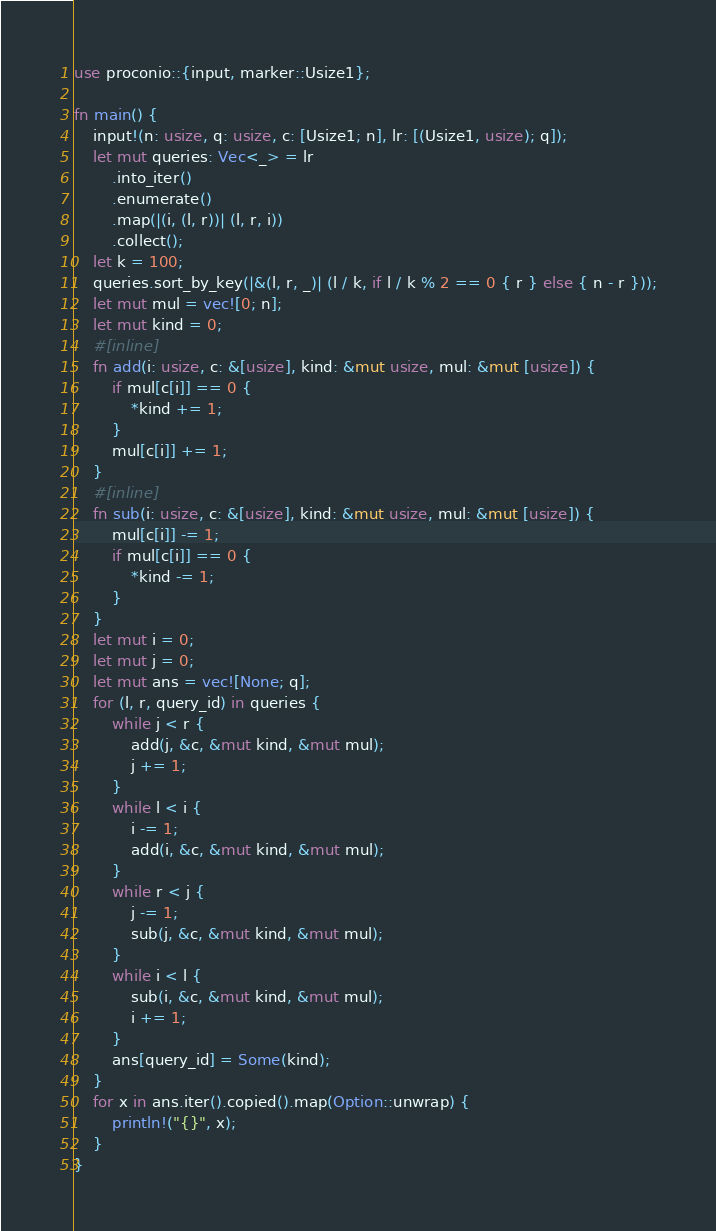<code> <loc_0><loc_0><loc_500><loc_500><_Rust_>use proconio::{input, marker::Usize1};

fn main() {
    input!(n: usize, q: usize, c: [Usize1; n], lr: [(Usize1, usize); q]);
    let mut queries: Vec<_> = lr
        .into_iter()
        .enumerate()
        .map(|(i, (l, r))| (l, r, i))
        .collect();
    let k = 100;
    queries.sort_by_key(|&(l, r, _)| (l / k, if l / k % 2 == 0 { r } else { n - r }));
    let mut mul = vec![0; n];
    let mut kind = 0;
    #[inline]
    fn add(i: usize, c: &[usize], kind: &mut usize, mul: &mut [usize]) {
        if mul[c[i]] == 0 {
            *kind += 1;
        }
        mul[c[i]] += 1;
    }
    #[inline]
    fn sub(i: usize, c: &[usize], kind: &mut usize, mul: &mut [usize]) {
        mul[c[i]] -= 1;
        if mul[c[i]] == 0 {
            *kind -= 1;
        }
    }
    let mut i = 0;
    let mut j = 0;
    let mut ans = vec![None; q];
    for (l, r, query_id) in queries {
        while j < r {
            add(j, &c, &mut kind, &mut mul);
            j += 1;
        }
        while l < i {
            i -= 1;
            add(i, &c, &mut kind, &mut mul);
        }
        while r < j {
            j -= 1;
            sub(j, &c, &mut kind, &mut mul);
        }
        while i < l {
            sub(i, &c, &mut kind, &mut mul);
            i += 1;
        }
        ans[query_id] = Some(kind);
    }
    for x in ans.iter().copied().map(Option::unwrap) {
        println!("{}", x);
    }
}
</code> 